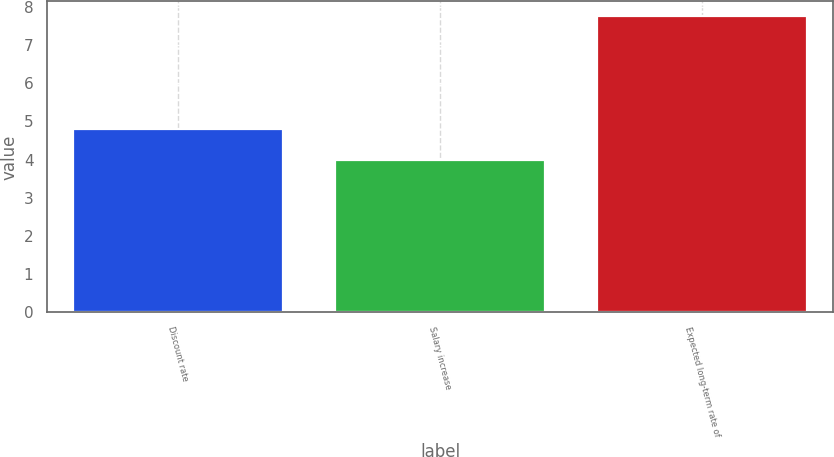Convert chart. <chart><loc_0><loc_0><loc_500><loc_500><bar_chart><fcel>Discount rate<fcel>Salary increase<fcel>Expected long-term rate of<nl><fcel>4.8<fcel>4<fcel>7.75<nl></chart> 